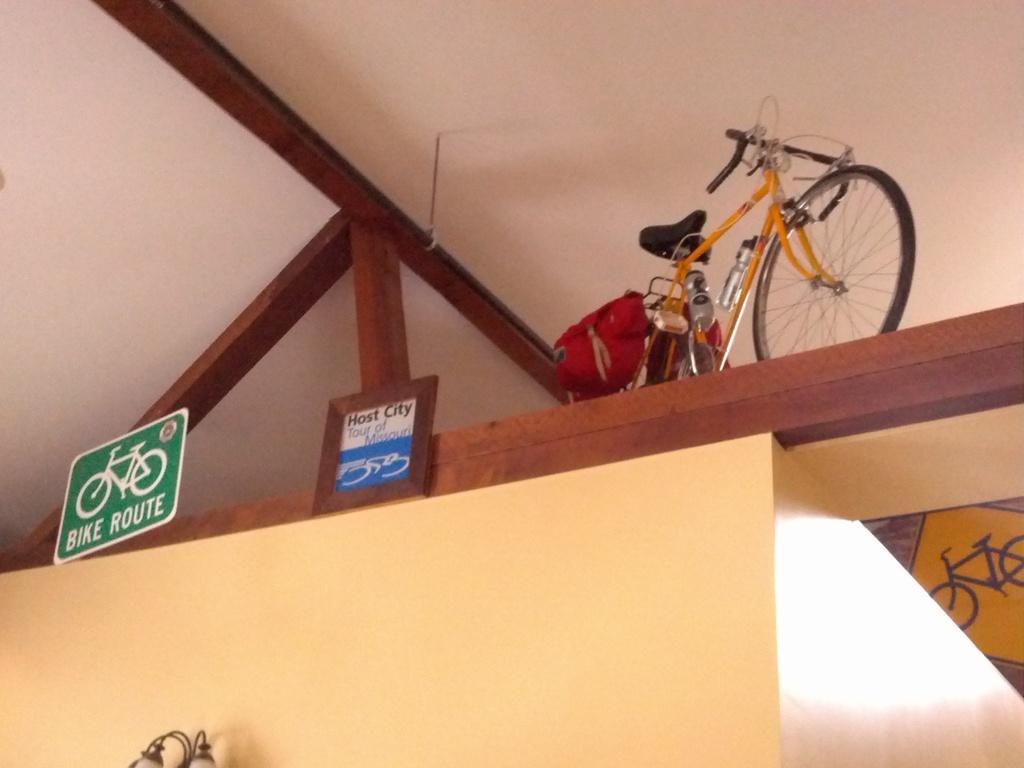Could you give a brief overview of what you see in this image? At the top we can see a bicycle. We can see two boards. The green color board stating "BIKE RIDE". Here we can see a wall and lights. 